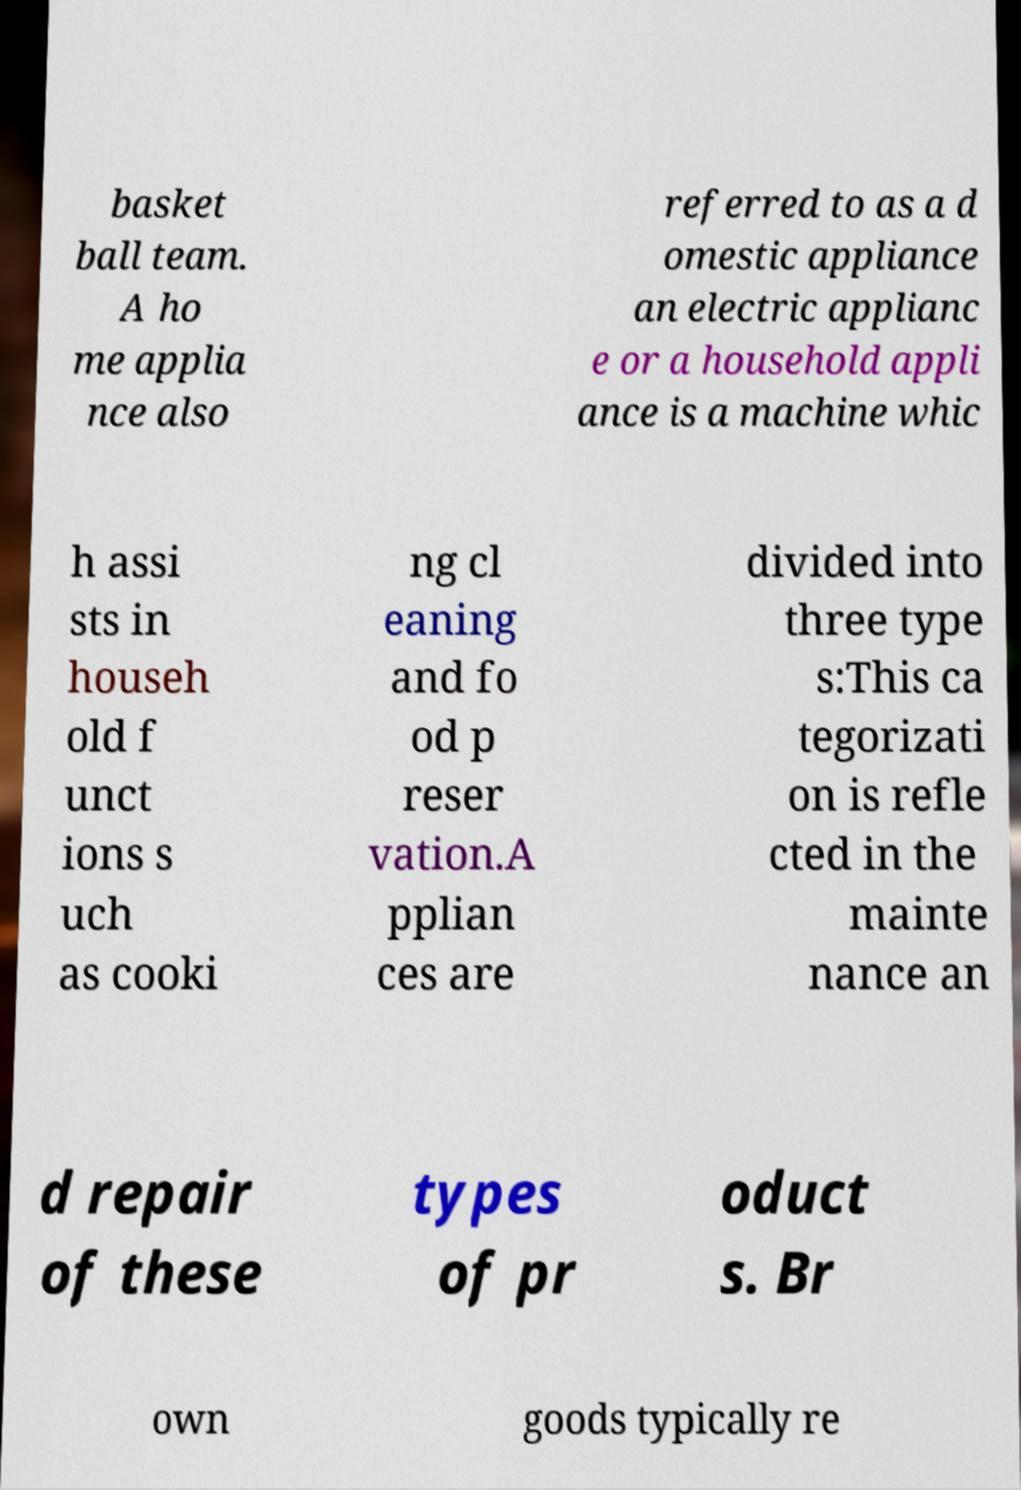There's text embedded in this image that I need extracted. Can you transcribe it verbatim? basket ball team. A ho me applia nce also referred to as a d omestic appliance an electric applianc e or a household appli ance is a machine whic h assi sts in househ old f unct ions s uch as cooki ng cl eaning and fo od p reser vation.A pplian ces are divided into three type s:This ca tegorizati on is refle cted in the mainte nance an d repair of these types of pr oduct s. Br own goods typically re 